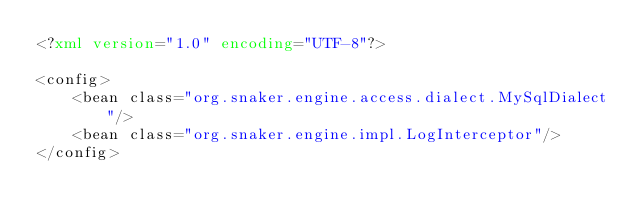<code> <loc_0><loc_0><loc_500><loc_500><_XML_><?xml version="1.0" encoding="UTF-8"?>

<config>
	<bean class="org.snaker.engine.access.dialect.MySqlDialect"/>
	<bean class="org.snaker.engine.impl.LogInterceptor"/>
</config></code> 